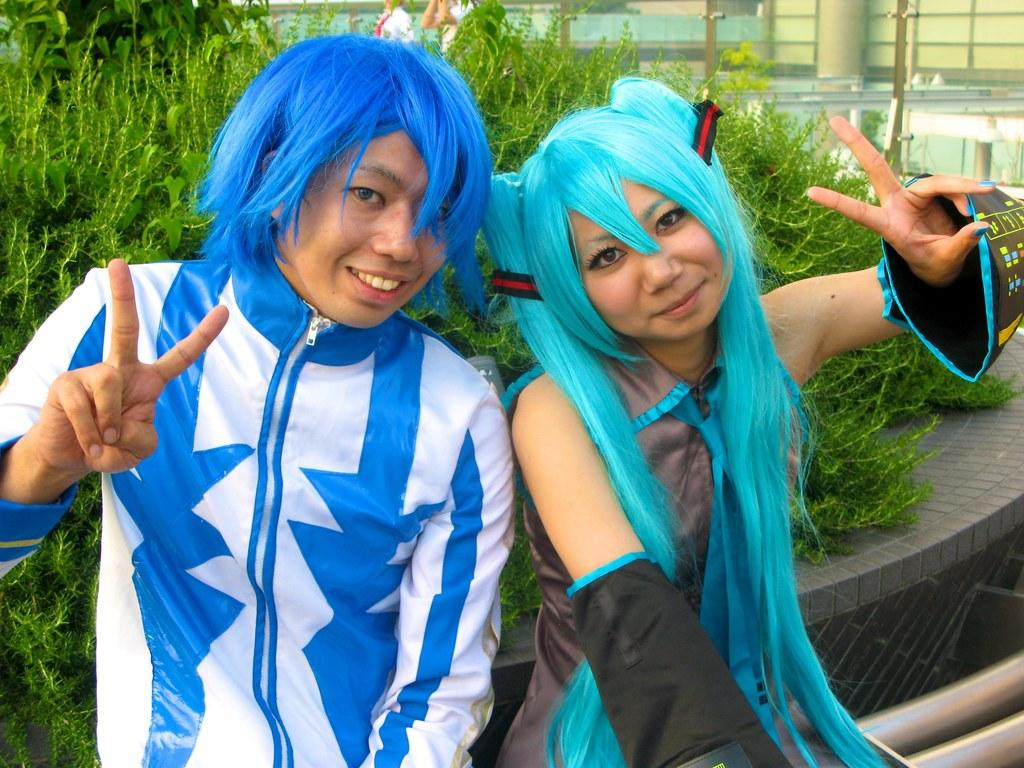What are the two persons in the middle of the image doing? The two persons in the middle of the image are sitting and smiling. What can be seen behind the sitting persons? There are plants visible behind the sitting persons. What are the two persons at the top of the image doing? The two persons at the top of the image are building something. How much salt is present in the image? There is no salt visible in the image. What type of plants can be seen begging for water in the image? There are no plants begging for water in the image; the plants are simply visible in the background. 